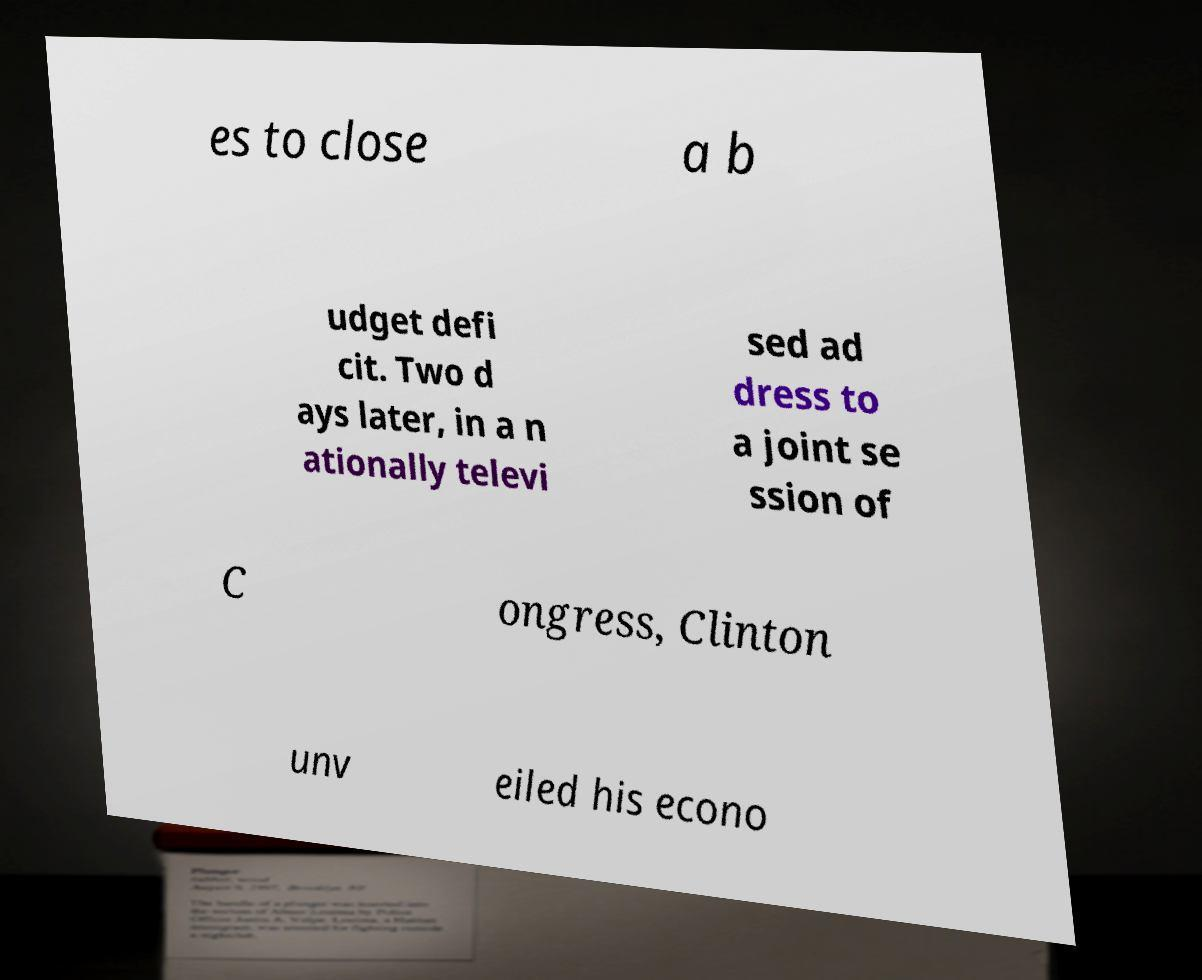Could you assist in decoding the text presented in this image and type it out clearly? es to close a b udget defi cit. Two d ays later, in a n ationally televi sed ad dress to a joint se ssion of C ongress, Clinton unv eiled his econo 